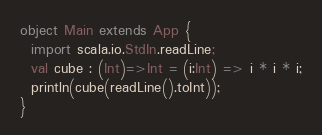Convert code to text. <code><loc_0><loc_0><loc_500><loc_500><_Scala_>object Main extends App {
  import scala.io.StdIn.readLine;
  val cube : (Int)=>Int = (i:Int) => i * i * i;
  println(cube(readLine().toInt));
}</code> 